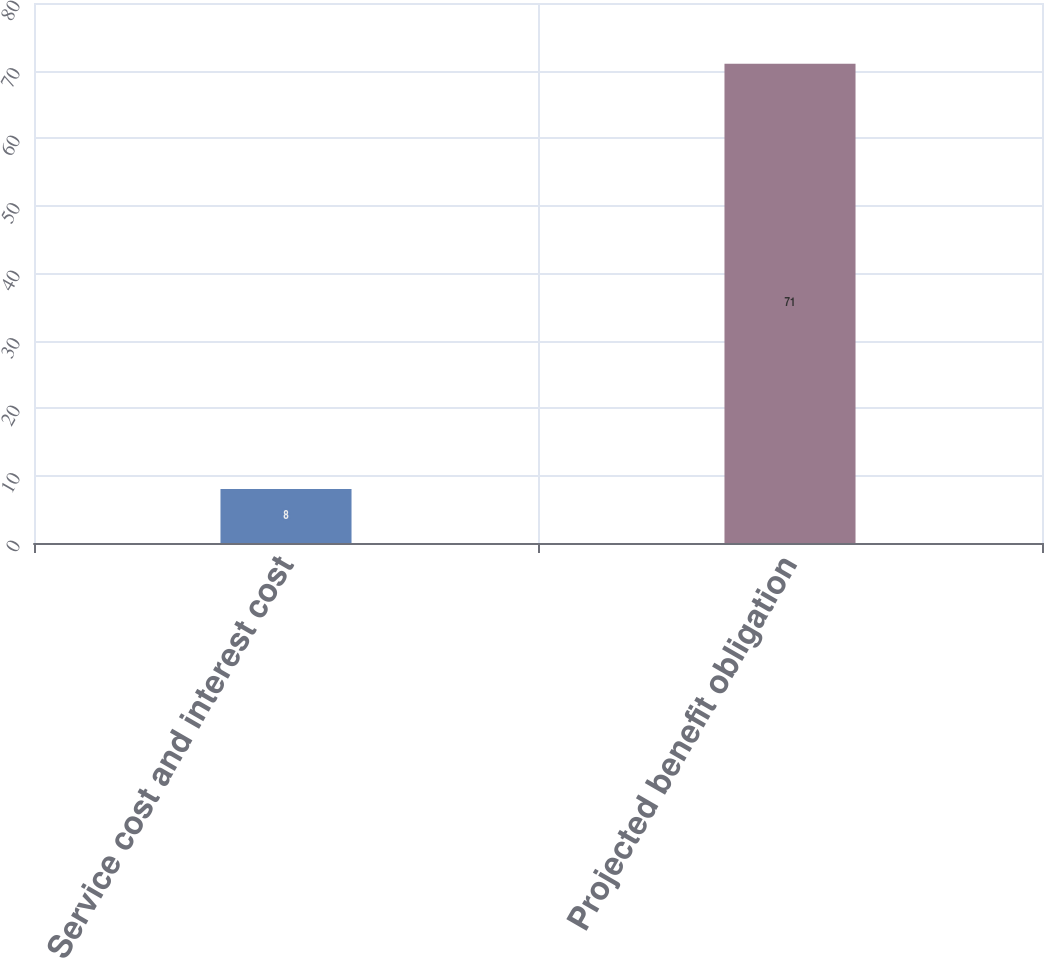<chart> <loc_0><loc_0><loc_500><loc_500><bar_chart><fcel>Service cost and interest cost<fcel>Projected benefit obligation<nl><fcel>8<fcel>71<nl></chart> 